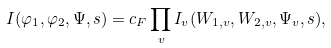Convert formula to latex. <formula><loc_0><loc_0><loc_500><loc_500>I ( \varphi _ { 1 } , \varphi _ { 2 } , \Psi , s ) = c _ { F } \prod _ { v } I _ { v } ( W _ { 1 , v } , W _ { 2 , v } , \Psi _ { v } , s ) ,</formula> 